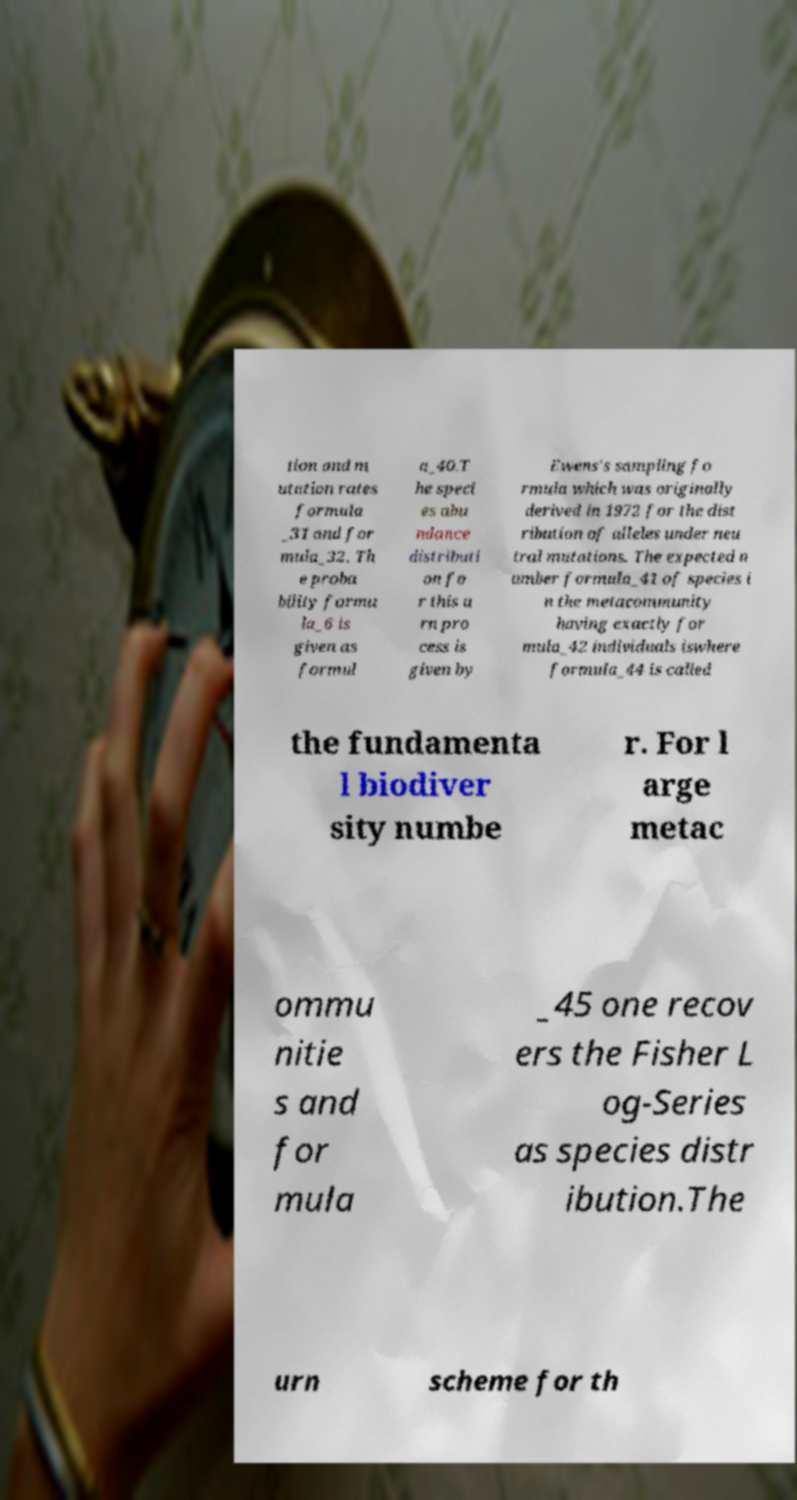Please read and relay the text visible in this image. What does it say? tion and m utation rates formula _31 and for mula_32. Th e proba bility formu la_6 is given as formul a_40.T he speci es abu ndance distributi on fo r this u rn pro cess is given by Ewens's sampling fo rmula which was originally derived in 1972 for the dist ribution of alleles under neu tral mutations. The expected n umber formula_41 of species i n the metacommunity having exactly for mula_42 individuals iswhere formula_44 is called the fundamenta l biodiver sity numbe r. For l arge metac ommu nitie s and for mula _45 one recov ers the Fisher L og-Series as species distr ibution.The urn scheme for th 